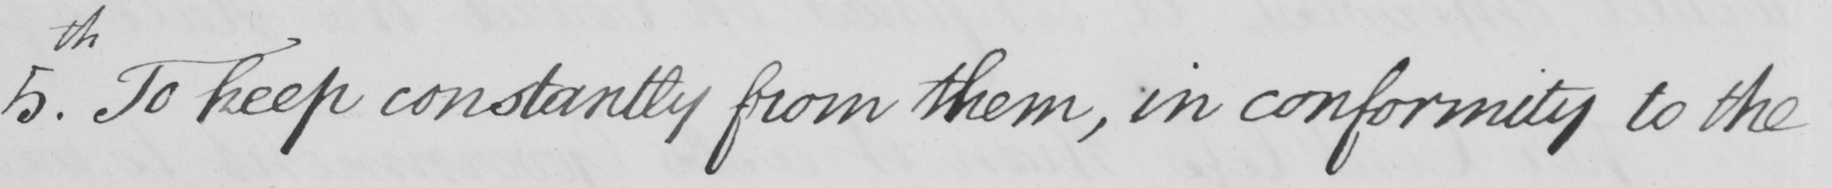Can you read and transcribe this handwriting? 5.th To keep constantly from them, in conformity to the 